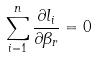<formula> <loc_0><loc_0><loc_500><loc_500>\sum _ { i = 1 } ^ { n } \frac { \partial l _ { i } } { \partial \beta _ { r } } = 0</formula> 